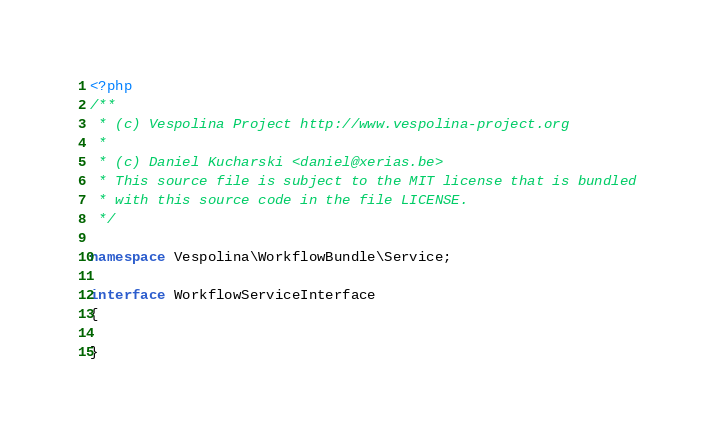Convert code to text. <code><loc_0><loc_0><loc_500><loc_500><_PHP_><?php
/**
 * (c) Vespolina Project http://www.vespolina-project.org
 *
 * (c) Daniel Kucharski <daniel@xerias.be>
 * This source file is subject to the MIT license that is bundled
 * with this source code in the file LICENSE.
 */
 
namespace Vespolina\WorkflowBundle\Service;

interface WorkflowServiceInterface
{
	
}
</code> 